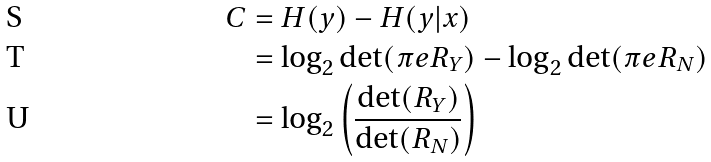<formula> <loc_0><loc_0><loc_500><loc_500>C & = H ( { y } ) - H ( { y } | { x } ) \\ & = \log _ { 2 } \det ( \pi e { R } _ { Y } ) - \log _ { 2 } \det ( \pi e { R } _ { N } ) \\ & = \log _ { 2 } \left ( \frac { \det ( { R } _ { Y } ) } { \det ( { R } _ { N } ) } \right )</formula> 